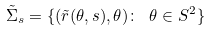Convert formula to latex. <formula><loc_0><loc_0><loc_500><loc_500>\tilde { \Sigma } _ { s } = \{ ( \tilde { r } ( \theta , s ) , \theta ) \colon \ \theta \in S ^ { 2 } \}</formula> 